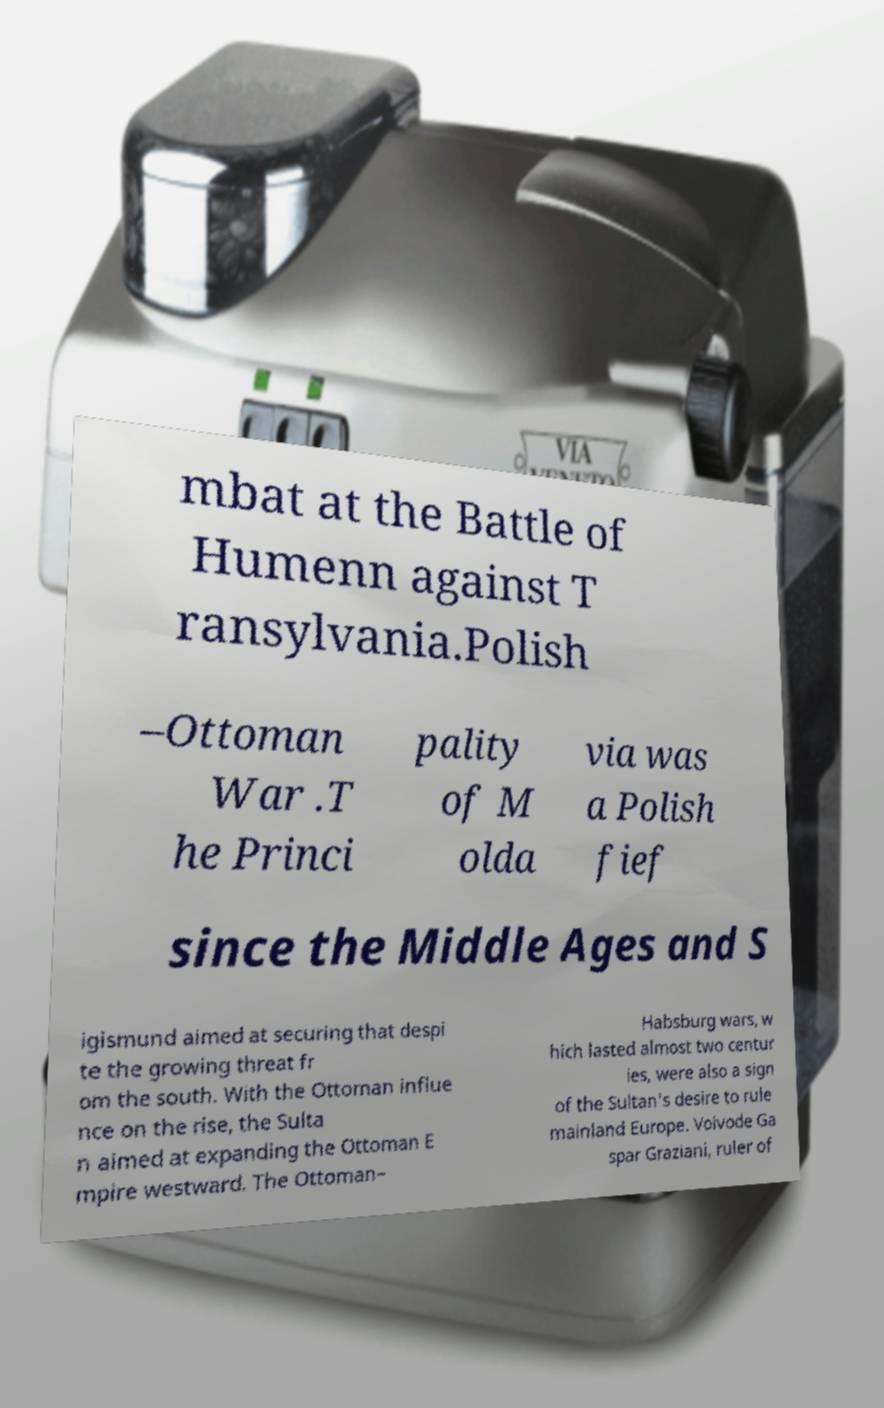I need the written content from this picture converted into text. Can you do that? mbat at the Battle of Humenn against T ransylvania.Polish –Ottoman War .T he Princi pality of M olda via was a Polish fief since the Middle Ages and S igismund aimed at securing that despi te the growing threat fr om the south. With the Ottoman influe nce on the rise, the Sulta n aimed at expanding the Ottoman E mpire westward. The Ottoman– Habsburg wars, w hich lasted almost two centur ies, were also a sign of the Sultan's desire to rule mainland Europe. Voivode Ga spar Graziani, ruler of 